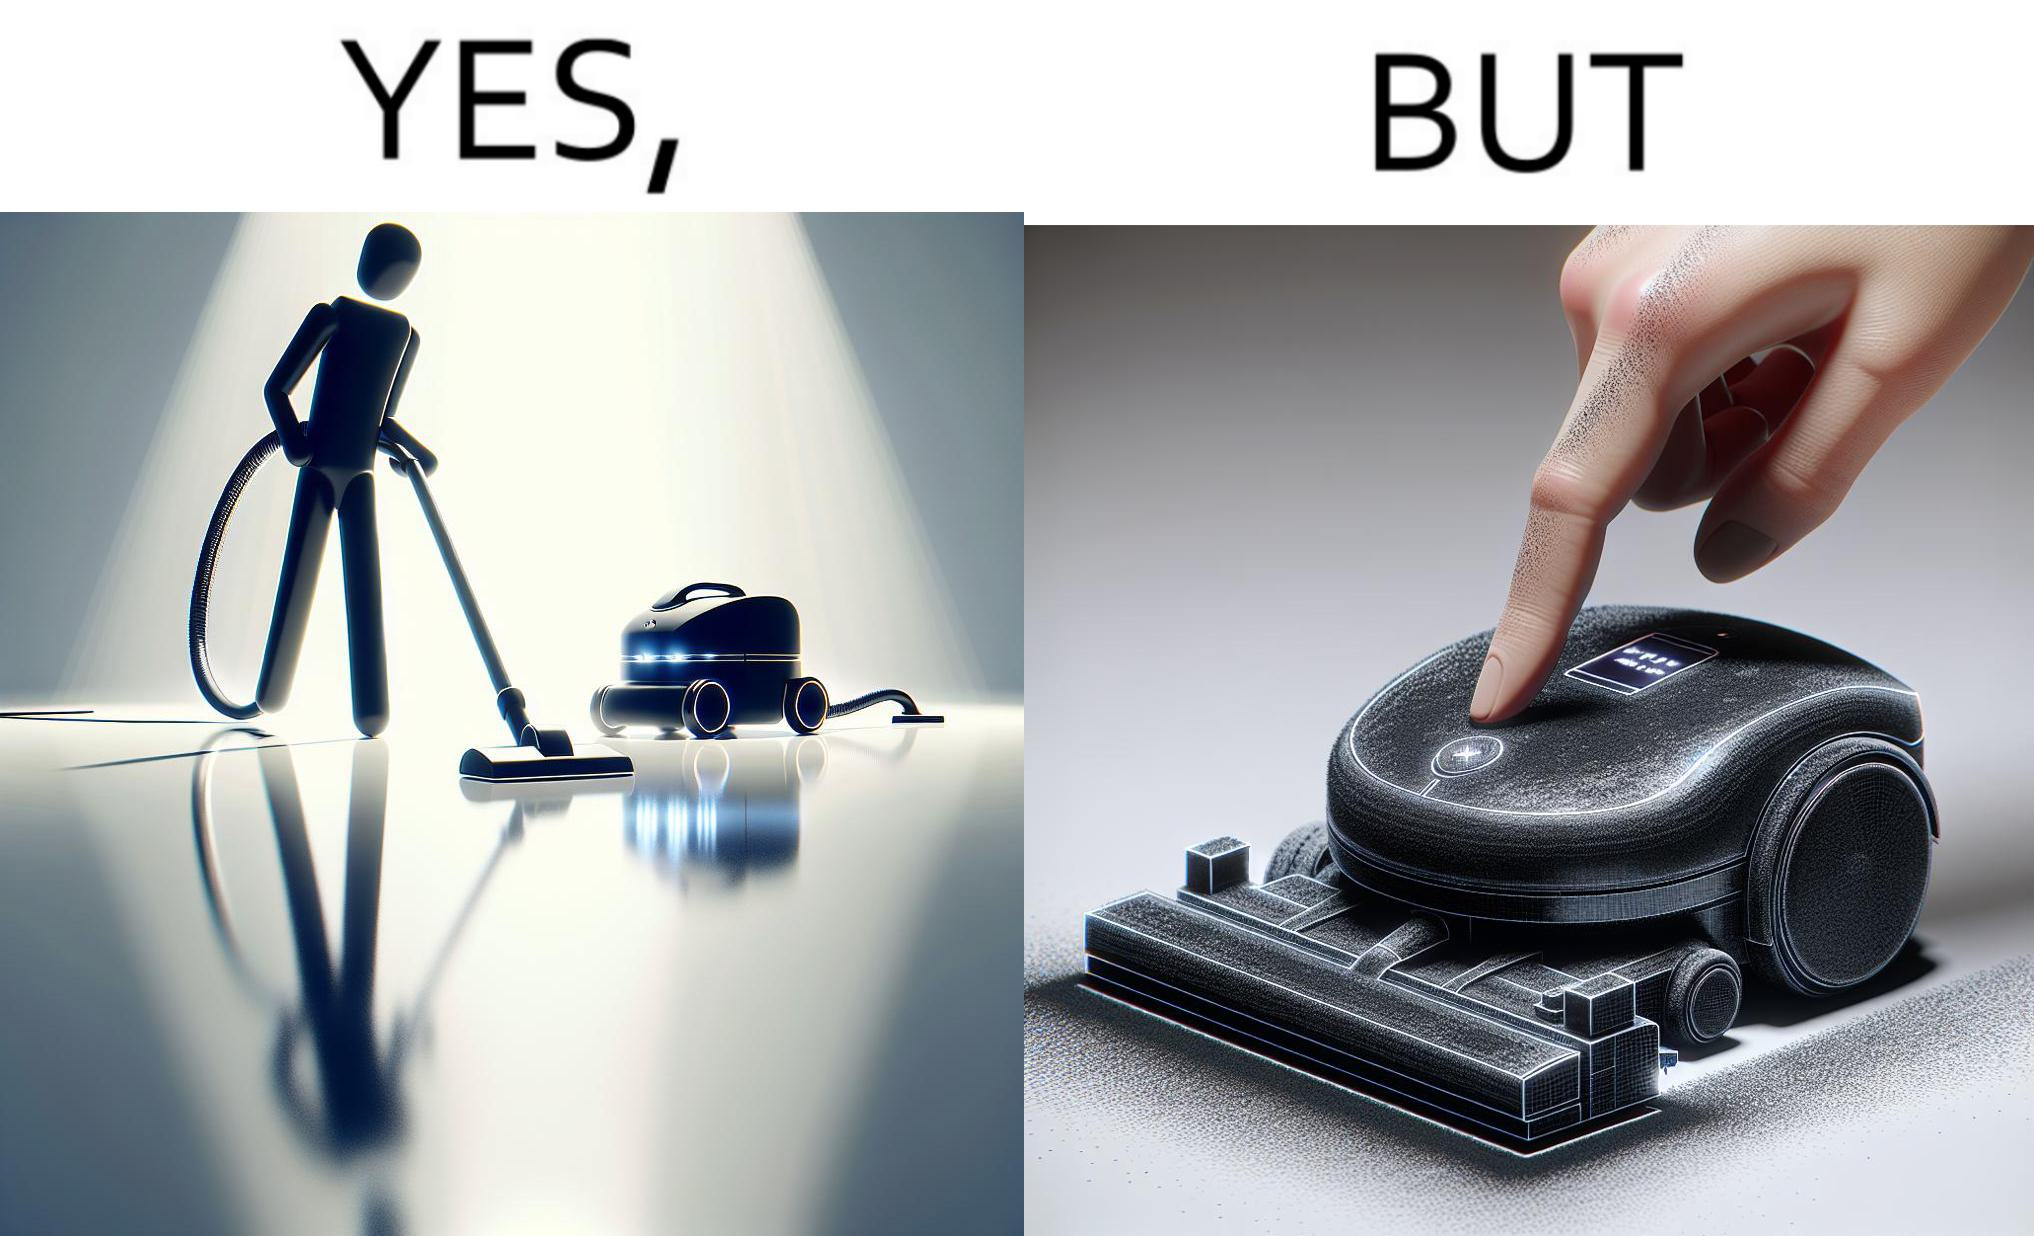Describe what you see in this image. This is funny, because the machine while doing its job cleans everything but ends up being dirty itself. 